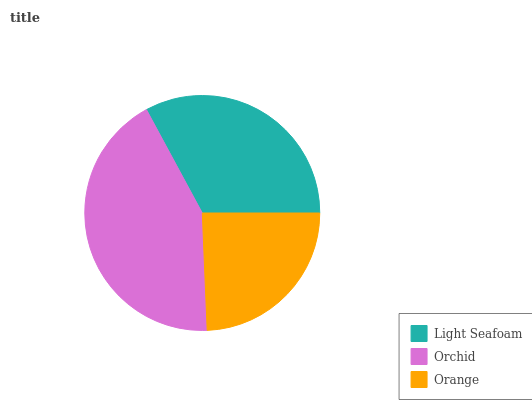Is Orange the minimum?
Answer yes or no. Yes. Is Orchid the maximum?
Answer yes or no. Yes. Is Orchid the minimum?
Answer yes or no. No. Is Orange the maximum?
Answer yes or no. No. Is Orchid greater than Orange?
Answer yes or no. Yes. Is Orange less than Orchid?
Answer yes or no. Yes. Is Orange greater than Orchid?
Answer yes or no. No. Is Orchid less than Orange?
Answer yes or no. No. Is Light Seafoam the high median?
Answer yes or no. Yes. Is Light Seafoam the low median?
Answer yes or no. Yes. Is Orange the high median?
Answer yes or no. No. Is Orchid the low median?
Answer yes or no. No. 